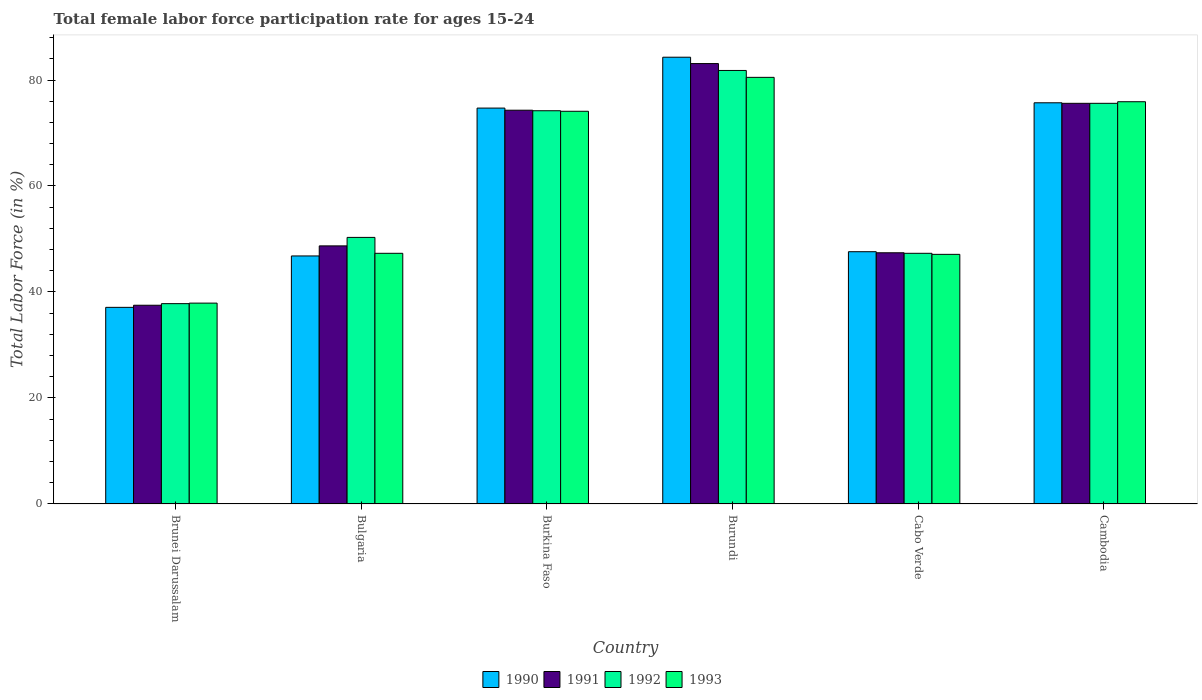How many bars are there on the 5th tick from the right?
Provide a succinct answer. 4. What is the female labor force participation rate in 1990 in Burundi?
Provide a succinct answer. 84.3. Across all countries, what is the maximum female labor force participation rate in 1993?
Make the answer very short. 80.5. Across all countries, what is the minimum female labor force participation rate in 1991?
Your answer should be compact. 37.5. In which country was the female labor force participation rate in 1992 maximum?
Make the answer very short. Burundi. In which country was the female labor force participation rate in 1992 minimum?
Keep it short and to the point. Brunei Darussalam. What is the total female labor force participation rate in 1991 in the graph?
Make the answer very short. 366.6. What is the difference between the female labor force participation rate in 1993 in Bulgaria and that in Burkina Faso?
Your response must be concise. -26.8. What is the difference between the female labor force participation rate in 1992 in Cabo Verde and the female labor force participation rate in 1991 in Burundi?
Make the answer very short. -35.8. What is the average female labor force participation rate in 1993 per country?
Your response must be concise. 60.47. What is the difference between the female labor force participation rate of/in 1990 and female labor force participation rate of/in 1992 in Brunei Darussalam?
Ensure brevity in your answer.  -0.7. What is the ratio of the female labor force participation rate in 1993 in Bulgaria to that in Cambodia?
Your answer should be compact. 0.62. What is the difference between the highest and the second highest female labor force participation rate in 1992?
Keep it short and to the point. 7.6. What is the difference between the highest and the lowest female labor force participation rate in 1993?
Give a very brief answer. 42.6. Is the sum of the female labor force participation rate in 1990 in Burundi and Cabo Verde greater than the maximum female labor force participation rate in 1991 across all countries?
Provide a short and direct response. Yes. Is it the case that in every country, the sum of the female labor force participation rate in 1990 and female labor force participation rate in 1993 is greater than the sum of female labor force participation rate in 1991 and female labor force participation rate in 1992?
Keep it short and to the point. No. What does the 4th bar from the left in Cambodia represents?
Provide a short and direct response. 1993. How many bars are there?
Offer a very short reply. 24. How many countries are there in the graph?
Make the answer very short. 6. What is the difference between two consecutive major ticks on the Y-axis?
Your response must be concise. 20. Are the values on the major ticks of Y-axis written in scientific E-notation?
Your response must be concise. No. Does the graph contain any zero values?
Ensure brevity in your answer.  No. Does the graph contain grids?
Provide a succinct answer. No. How are the legend labels stacked?
Offer a terse response. Horizontal. What is the title of the graph?
Keep it short and to the point. Total female labor force participation rate for ages 15-24. Does "2001" appear as one of the legend labels in the graph?
Your answer should be compact. No. What is the label or title of the X-axis?
Your answer should be very brief. Country. What is the label or title of the Y-axis?
Offer a terse response. Total Labor Force (in %). What is the Total Labor Force (in %) of 1990 in Brunei Darussalam?
Provide a succinct answer. 37.1. What is the Total Labor Force (in %) in 1991 in Brunei Darussalam?
Offer a very short reply. 37.5. What is the Total Labor Force (in %) of 1992 in Brunei Darussalam?
Provide a succinct answer. 37.8. What is the Total Labor Force (in %) of 1993 in Brunei Darussalam?
Keep it short and to the point. 37.9. What is the Total Labor Force (in %) of 1990 in Bulgaria?
Your answer should be compact. 46.8. What is the Total Labor Force (in %) in 1991 in Bulgaria?
Your answer should be very brief. 48.7. What is the Total Labor Force (in %) in 1992 in Bulgaria?
Offer a terse response. 50.3. What is the Total Labor Force (in %) of 1993 in Bulgaria?
Your answer should be very brief. 47.3. What is the Total Labor Force (in %) in 1990 in Burkina Faso?
Your response must be concise. 74.7. What is the Total Labor Force (in %) in 1991 in Burkina Faso?
Keep it short and to the point. 74.3. What is the Total Labor Force (in %) in 1992 in Burkina Faso?
Offer a terse response. 74.2. What is the Total Labor Force (in %) in 1993 in Burkina Faso?
Provide a succinct answer. 74.1. What is the Total Labor Force (in %) of 1990 in Burundi?
Give a very brief answer. 84.3. What is the Total Labor Force (in %) of 1991 in Burundi?
Your answer should be compact. 83.1. What is the Total Labor Force (in %) of 1992 in Burundi?
Your answer should be very brief. 81.8. What is the Total Labor Force (in %) of 1993 in Burundi?
Ensure brevity in your answer.  80.5. What is the Total Labor Force (in %) of 1990 in Cabo Verde?
Ensure brevity in your answer.  47.6. What is the Total Labor Force (in %) of 1991 in Cabo Verde?
Offer a very short reply. 47.4. What is the Total Labor Force (in %) in 1992 in Cabo Verde?
Ensure brevity in your answer.  47.3. What is the Total Labor Force (in %) in 1993 in Cabo Verde?
Your answer should be compact. 47.1. What is the Total Labor Force (in %) of 1990 in Cambodia?
Keep it short and to the point. 75.7. What is the Total Labor Force (in %) in 1991 in Cambodia?
Provide a short and direct response. 75.6. What is the Total Labor Force (in %) of 1992 in Cambodia?
Your response must be concise. 75.6. What is the Total Labor Force (in %) in 1993 in Cambodia?
Your answer should be very brief. 75.9. Across all countries, what is the maximum Total Labor Force (in %) of 1990?
Your answer should be compact. 84.3. Across all countries, what is the maximum Total Labor Force (in %) in 1991?
Your answer should be very brief. 83.1. Across all countries, what is the maximum Total Labor Force (in %) of 1992?
Offer a very short reply. 81.8. Across all countries, what is the maximum Total Labor Force (in %) in 1993?
Your answer should be compact. 80.5. Across all countries, what is the minimum Total Labor Force (in %) in 1990?
Keep it short and to the point. 37.1. Across all countries, what is the minimum Total Labor Force (in %) in 1991?
Ensure brevity in your answer.  37.5. Across all countries, what is the minimum Total Labor Force (in %) in 1992?
Your response must be concise. 37.8. Across all countries, what is the minimum Total Labor Force (in %) of 1993?
Offer a terse response. 37.9. What is the total Total Labor Force (in %) of 1990 in the graph?
Keep it short and to the point. 366.2. What is the total Total Labor Force (in %) in 1991 in the graph?
Provide a short and direct response. 366.6. What is the total Total Labor Force (in %) in 1992 in the graph?
Offer a terse response. 367. What is the total Total Labor Force (in %) of 1993 in the graph?
Your answer should be very brief. 362.8. What is the difference between the Total Labor Force (in %) of 1990 in Brunei Darussalam and that in Bulgaria?
Make the answer very short. -9.7. What is the difference between the Total Labor Force (in %) in 1991 in Brunei Darussalam and that in Bulgaria?
Offer a terse response. -11.2. What is the difference between the Total Labor Force (in %) of 1990 in Brunei Darussalam and that in Burkina Faso?
Offer a very short reply. -37.6. What is the difference between the Total Labor Force (in %) in 1991 in Brunei Darussalam and that in Burkina Faso?
Your answer should be compact. -36.8. What is the difference between the Total Labor Force (in %) in 1992 in Brunei Darussalam and that in Burkina Faso?
Your response must be concise. -36.4. What is the difference between the Total Labor Force (in %) of 1993 in Brunei Darussalam and that in Burkina Faso?
Offer a terse response. -36.2. What is the difference between the Total Labor Force (in %) of 1990 in Brunei Darussalam and that in Burundi?
Provide a short and direct response. -47.2. What is the difference between the Total Labor Force (in %) in 1991 in Brunei Darussalam and that in Burundi?
Ensure brevity in your answer.  -45.6. What is the difference between the Total Labor Force (in %) in 1992 in Brunei Darussalam and that in Burundi?
Offer a very short reply. -44. What is the difference between the Total Labor Force (in %) of 1993 in Brunei Darussalam and that in Burundi?
Keep it short and to the point. -42.6. What is the difference between the Total Labor Force (in %) in 1992 in Brunei Darussalam and that in Cabo Verde?
Keep it short and to the point. -9.5. What is the difference between the Total Labor Force (in %) in 1993 in Brunei Darussalam and that in Cabo Verde?
Make the answer very short. -9.2. What is the difference between the Total Labor Force (in %) in 1990 in Brunei Darussalam and that in Cambodia?
Your response must be concise. -38.6. What is the difference between the Total Labor Force (in %) in 1991 in Brunei Darussalam and that in Cambodia?
Provide a short and direct response. -38.1. What is the difference between the Total Labor Force (in %) in 1992 in Brunei Darussalam and that in Cambodia?
Ensure brevity in your answer.  -37.8. What is the difference between the Total Labor Force (in %) of 1993 in Brunei Darussalam and that in Cambodia?
Keep it short and to the point. -38. What is the difference between the Total Labor Force (in %) in 1990 in Bulgaria and that in Burkina Faso?
Provide a short and direct response. -27.9. What is the difference between the Total Labor Force (in %) of 1991 in Bulgaria and that in Burkina Faso?
Offer a terse response. -25.6. What is the difference between the Total Labor Force (in %) of 1992 in Bulgaria and that in Burkina Faso?
Your response must be concise. -23.9. What is the difference between the Total Labor Force (in %) of 1993 in Bulgaria and that in Burkina Faso?
Keep it short and to the point. -26.8. What is the difference between the Total Labor Force (in %) in 1990 in Bulgaria and that in Burundi?
Keep it short and to the point. -37.5. What is the difference between the Total Labor Force (in %) in 1991 in Bulgaria and that in Burundi?
Offer a terse response. -34.4. What is the difference between the Total Labor Force (in %) in 1992 in Bulgaria and that in Burundi?
Provide a succinct answer. -31.5. What is the difference between the Total Labor Force (in %) of 1993 in Bulgaria and that in Burundi?
Your response must be concise. -33.2. What is the difference between the Total Labor Force (in %) in 1990 in Bulgaria and that in Cabo Verde?
Offer a very short reply. -0.8. What is the difference between the Total Labor Force (in %) in 1990 in Bulgaria and that in Cambodia?
Offer a very short reply. -28.9. What is the difference between the Total Labor Force (in %) of 1991 in Bulgaria and that in Cambodia?
Ensure brevity in your answer.  -26.9. What is the difference between the Total Labor Force (in %) of 1992 in Bulgaria and that in Cambodia?
Provide a short and direct response. -25.3. What is the difference between the Total Labor Force (in %) in 1993 in Bulgaria and that in Cambodia?
Your answer should be compact. -28.6. What is the difference between the Total Labor Force (in %) of 1992 in Burkina Faso and that in Burundi?
Give a very brief answer. -7.6. What is the difference between the Total Labor Force (in %) in 1993 in Burkina Faso and that in Burundi?
Provide a short and direct response. -6.4. What is the difference between the Total Labor Force (in %) in 1990 in Burkina Faso and that in Cabo Verde?
Offer a terse response. 27.1. What is the difference between the Total Labor Force (in %) of 1991 in Burkina Faso and that in Cabo Verde?
Provide a succinct answer. 26.9. What is the difference between the Total Labor Force (in %) of 1992 in Burkina Faso and that in Cabo Verde?
Offer a very short reply. 26.9. What is the difference between the Total Labor Force (in %) in 1993 in Burkina Faso and that in Cambodia?
Make the answer very short. -1.8. What is the difference between the Total Labor Force (in %) of 1990 in Burundi and that in Cabo Verde?
Provide a short and direct response. 36.7. What is the difference between the Total Labor Force (in %) in 1991 in Burundi and that in Cabo Verde?
Keep it short and to the point. 35.7. What is the difference between the Total Labor Force (in %) of 1992 in Burundi and that in Cabo Verde?
Keep it short and to the point. 34.5. What is the difference between the Total Labor Force (in %) in 1993 in Burundi and that in Cabo Verde?
Your answer should be compact. 33.4. What is the difference between the Total Labor Force (in %) in 1991 in Burundi and that in Cambodia?
Make the answer very short. 7.5. What is the difference between the Total Labor Force (in %) of 1993 in Burundi and that in Cambodia?
Ensure brevity in your answer.  4.6. What is the difference between the Total Labor Force (in %) in 1990 in Cabo Verde and that in Cambodia?
Keep it short and to the point. -28.1. What is the difference between the Total Labor Force (in %) of 1991 in Cabo Verde and that in Cambodia?
Your response must be concise. -28.2. What is the difference between the Total Labor Force (in %) in 1992 in Cabo Verde and that in Cambodia?
Keep it short and to the point. -28.3. What is the difference between the Total Labor Force (in %) of 1993 in Cabo Verde and that in Cambodia?
Your response must be concise. -28.8. What is the difference between the Total Labor Force (in %) in 1990 in Brunei Darussalam and the Total Labor Force (in %) in 1992 in Bulgaria?
Make the answer very short. -13.2. What is the difference between the Total Labor Force (in %) in 1990 in Brunei Darussalam and the Total Labor Force (in %) in 1991 in Burkina Faso?
Keep it short and to the point. -37.2. What is the difference between the Total Labor Force (in %) in 1990 in Brunei Darussalam and the Total Labor Force (in %) in 1992 in Burkina Faso?
Make the answer very short. -37.1. What is the difference between the Total Labor Force (in %) of 1990 in Brunei Darussalam and the Total Labor Force (in %) of 1993 in Burkina Faso?
Your response must be concise. -37. What is the difference between the Total Labor Force (in %) of 1991 in Brunei Darussalam and the Total Labor Force (in %) of 1992 in Burkina Faso?
Provide a succinct answer. -36.7. What is the difference between the Total Labor Force (in %) of 1991 in Brunei Darussalam and the Total Labor Force (in %) of 1993 in Burkina Faso?
Your response must be concise. -36.6. What is the difference between the Total Labor Force (in %) in 1992 in Brunei Darussalam and the Total Labor Force (in %) in 1993 in Burkina Faso?
Offer a terse response. -36.3. What is the difference between the Total Labor Force (in %) of 1990 in Brunei Darussalam and the Total Labor Force (in %) of 1991 in Burundi?
Your answer should be compact. -46. What is the difference between the Total Labor Force (in %) in 1990 in Brunei Darussalam and the Total Labor Force (in %) in 1992 in Burundi?
Offer a very short reply. -44.7. What is the difference between the Total Labor Force (in %) of 1990 in Brunei Darussalam and the Total Labor Force (in %) of 1993 in Burundi?
Your answer should be very brief. -43.4. What is the difference between the Total Labor Force (in %) of 1991 in Brunei Darussalam and the Total Labor Force (in %) of 1992 in Burundi?
Make the answer very short. -44.3. What is the difference between the Total Labor Force (in %) in 1991 in Brunei Darussalam and the Total Labor Force (in %) in 1993 in Burundi?
Your answer should be very brief. -43. What is the difference between the Total Labor Force (in %) of 1992 in Brunei Darussalam and the Total Labor Force (in %) of 1993 in Burundi?
Keep it short and to the point. -42.7. What is the difference between the Total Labor Force (in %) of 1990 in Brunei Darussalam and the Total Labor Force (in %) of 1991 in Cabo Verde?
Ensure brevity in your answer.  -10.3. What is the difference between the Total Labor Force (in %) in 1990 in Brunei Darussalam and the Total Labor Force (in %) in 1992 in Cabo Verde?
Provide a succinct answer. -10.2. What is the difference between the Total Labor Force (in %) in 1990 in Brunei Darussalam and the Total Labor Force (in %) in 1993 in Cabo Verde?
Your response must be concise. -10. What is the difference between the Total Labor Force (in %) in 1991 in Brunei Darussalam and the Total Labor Force (in %) in 1993 in Cabo Verde?
Your answer should be very brief. -9.6. What is the difference between the Total Labor Force (in %) of 1990 in Brunei Darussalam and the Total Labor Force (in %) of 1991 in Cambodia?
Provide a succinct answer. -38.5. What is the difference between the Total Labor Force (in %) of 1990 in Brunei Darussalam and the Total Labor Force (in %) of 1992 in Cambodia?
Give a very brief answer. -38.5. What is the difference between the Total Labor Force (in %) in 1990 in Brunei Darussalam and the Total Labor Force (in %) in 1993 in Cambodia?
Your answer should be very brief. -38.8. What is the difference between the Total Labor Force (in %) in 1991 in Brunei Darussalam and the Total Labor Force (in %) in 1992 in Cambodia?
Your response must be concise. -38.1. What is the difference between the Total Labor Force (in %) in 1991 in Brunei Darussalam and the Total Labor Force (in %) in 1993 in Cambodia?
Your answer should be very brief. -38.4. What is the difference between the Total Labor Force (in %) in 1992 in Brunei Darussalam and the Total Labor Force (in %) in 1993 in Cambodia?
Keep it short and to the point. -38.1. What is the difference between the Total Labor Force (in %) in 1990 in Bulgaria and the Total Labor Force (in %) in 1991 in Burkina Faso?
Provide a succinct answer. -27.5. What is the difference between the Total Labor Force (in %) in 1990 in Bulgaria and the Total Labor Force (in %) in 1992 in Burkina Faso?
Offer a very short reply. -27.4. What is the difference between the Total Labor Force (in %) of 1990 in Bulgaria and the Total Labor Force (in %) of 1993 in Burkina Faso?
Offer a very short reply. -27.3. What is the difference between the Total Labor Force (in %) of 1991 in Bulgaria and the Total Labor Force (in %) of 1992 in Burkina Faso?
Provide a succinct answer. -25.5. What is the difference between the Total Labor Force (in %) of 1991 in Bulgaria and the Total Labor Force (in %) of 1993 in Burkina Faso?
Your answer should be compact. -25.4. What is the difference between the Total Labor Force (in %) in 1992 in Bulgaria and the Total Labor Force (in %) in 1993 in Burkina Faso?
Keep it short and to the point. -23.8. What is the difference between the Total Labor Force (in %) in 1990 in Bulgaria and the Total Labor Force (in %) in 1991 in Burundi?
Your answer should be compact. -36.3. What is the difference between the Total Labor Force (in %) of 1990 in Bulgaria and the Total Labor Force (in %) of 1992 in Burundi?
Your response must be concise. -35. What is the difference between the Total Labor Force (in %) of 1990 in Bulgaria and the Total Labor Force (in %) of 1993 in Burundi?
Ensure brevity in your answer.  -33.7. What is the difference between the Total Labor Force (in %) in 1991 in Bulgaria and the Total Labor Force (in %) in 1992 in Burundi?
Keep it short and to the point. -33.1. What is the difference between the Total Labor Force (in %) in 1991 in Bulgaria and the Total Labor Force (in %) in 1993 in Burundi?
Offer a terse response. -31.8. What is the difference between the Total Labor Force (in %) in 1992 in Bulgaria and the Total Labor Force (in %) in 1993 in Burundi?
Your answer should be very brief. -30.2. What is the difference between the Total Labor Force (in %) of 1990 in Bulgaria and the Total Labor Force (in %) of 1992 in Cabo Verde?
Keep it short and to the point. -0.5. What is the difference between the Total Labor Force (in %) of 1991 in Bulgaria and the Total Labor Force (in %) of 1992 in Cabo Verde?
Provide a short and direct response. 1.4. What is the difference between the Total Labor Force (in %) of 1990 in Bulgaria and the Total Labor Force (in %) of 1991 in Cambodia?
Your answer should be very brief. -28.8. What is the difference between the Total Labor Force (in %) of 1990 in Bulgaria and the Total Labor Force (in %) of 1992 in Cambodia?
Provide a short and direct response. -28.8. What is the difference between the Total Labor Force (in %) in 1990 in Bulgaria and the Total Labor Force (in %) in 1993 in Cambodia?
Make the answer very short. -29.1. What is the difference between the Total Labor Force (in %) of 1991 in Bulgaria and the Total Labor Force (in %) of 1992 in Cambodia?
Give a very brief answer. -26.9. What is the difference between the Total Labor Force (in %) of 1991 in Bulgaria and the Total Labor Force (in %) of 1993 in Cambodia?
Keep it short and to the point. -27.2. What is the difference between the Total Labor Force (in %) in 1992 in Bulgaria and the Total Labor Force (in %) in 1993 in Cambodia?
Your answer should be compact. -25.6. What is the difference between the Total Labor Force (in %) of 1990 in Burkina Faso and the Total Labor Force (in %) of 1991 in Burundi?
Offer a very short reply. -8.4. What is the difference between the Total Labor Force (in %) in 1990 in Burkina Faso and the Total Labor Force (in %) in 1992 in Burundi?
Your answer should be compact. -7.1. What is the difference between the Total Labor Force (in %) in 1990 in Burkina Faso and the Total Labor Force (in %) in 1993 in Burundi?
Keep it short and to the point. -5.8. What is the difference between the Total Labor Force (in %) of 1991 in Burkina Faso and the Total Labor Force (in %) of 1992 in Burundi?
Your answer should be very brief. -7.5. What is the difference between the Total Labor Force (in %) in 1990 in Burkina Faso and the Total Labor Force (in %) in 1991 in Cabo Verde?
Your response must be concise. 27.3. What is the difference between the Total Labor Force (in %) in 1990 in Burkina Faso and the Total Labor Force (in %) in 1992 in Cabo Verde?
Your answer should be very brief. 27.4. What is the difference between the Total Labor Force (in %) in 1990 in Burkina Faso and the Total Labor Force (in %) in 1993 in Cabo Verde?
Provide a short and direct response. 27.6. What is the difference between the Total Labor Force (in %) of 1991 in Burkina Faso and the Total Labor Force (in %) of 1992 in Cabo Verde?
Ensure brevity in your answer.  27. What is the difference between the Total Labor Force (in %) in 1991 in Burkina Faso and the Total Labor Force (in %) in 1993 in Cabo Verde?
Give a very brief answer. 27.2. What is the difference between the Total Labor Force (in %) of 1992 in Burkina Faso and the Total Labor Force (in %) of 1993 in Cabo Verde?
Your answer should be compact. 27.1. What is the difference between the Total Labor Force (in %) in 1990 in Burkina Faso and the Total Labor Force (in %) in 1992 in Cambodia?
Make the answer very short. -0.9. What is the difference between the Total Labor Force (in %) in 1991 in Burkina Faso and the Total Labor Force (in %) in 1993 in Cambodia?
Your answer should be compact. -1.6. What is the difference between the Total Labor Force (in %) of 1992 in Burkina Faso and the Total Labor Force (in %) of 1993 in Cambodia?
Make the answer very short. -1.7. What is the difference between the Total Labor Force (in %) of 1990 in Burundi and the Total Labor Force (in %) of 1991 in Cabo Verde?
Offer a very short reply. 36.9. What is the difference between the Total Labor Force (in %) of 1990 in Burundi and the Total Labor Force (in %) of 1992 in Cabo Verde?
Offer a terse response. 37. What is the difference between the Total Labor Force (in %) in 1990 in Burundi and the Total Labor Force (in %) in 1993 in Cabo Verde?
Your answer should be compact. 37.2. What is the difference between the Total Labor Force (in %) of 1991 in Burundi and the Total Labor Force (in %) of 1992 in Cabo Verde?
Your answer should be very brief. 35.8. What is the difference between the Total Labor Force (in %) of 1992 in Burundi and the Total Labor Force (in %) of 1993 in Cabo Verde?
Offer a very short reply. 34.7. What is the difference between the Total Labor Force (in %) in 1990 in Burundi and the Total Labor Force (in %) in 1992 in Cambodia?
Give a very brief answer. 8.7. What is the difference between the Total Labor Force (in %) in 1991 in Burundi and the Total Labor Force (in %) in 1992 in Cambodia?
Provide a short and direct response. 7.5. What is the difference between the Total Labor Force (in %) of 1991 in Burundi and the Total Labor Force (in %) of 1993 in Cambodia?
Make the answer very short. 7.2. What is the difference between the Total Labor Force (in %) of 1992 in Burundi and the Total Labor Force (in %) of 1993 in Cambodia?
Make the answer very short. 5.9. What is the difference between the Total Labor Force (in %) of 1990 in Cabo Verde and the Total Labor Force (in %) of 1991 in Cambodia?
Keep it short and to the point. -28. What is the difference between the Total Labor Force (in %) of 1990 in Cabo Verde and the Total Labor Force (in %) of 1993 in Cambodia?
Give a very brief answer. -28.3. What is the difference between the Total Labor Force (in %) in 1991 in Cabo Verde and the Total Labor Force (in %) in 1992 in Cambodia?
Your answer should be compact. -28.2. What is the difference between the Total Labor Force (in %) of 1991 in Cabo Verde and the Total Labor Force (in %) of 1993 in Cambodia?
Keep it short and to the point. -28.5. What is the difference between the Total Labor Force (in %) of 1992 in Cabo Verde and the Total Labor Force (in %) of 1993 in Cambodia?
Your response must be concise. -28.6. What is the average Total Labor Force (in %) in 1990 per country?
Keep it short and to the point. 61.03. What is the average Total Labor Force (in %) in 1991 per country?
Ensure brevity in your answer.  61.1. What is the average Total Labor Force (in %) of 1992 per country?
Provide a short and direct response. 61.17. What is the average Total Labor Force (in %) in 1993 per country?
Provide a succinct answer. 60.47. What is the difference between the Total Labor Force (in %) of 1990 and Total Labor Force (in %) of 1992 in Brunei Darussalam?
Offer a very short reply. -0.7. What is the difference between the Total Labor Force (in %) of 1990 and Total Labor Force (in %) of 1993 in Brunei Darussalam?
Provide a succinct answer. -0.8. What is the difference between the Total Labor Force (in %) of 1991 and Total Labor Force (in %) of 1993 in Brunei Darussalam?
Provide a succinct answer. -0.4. What is the difference between the Total Labor Force (in %) in 1992 and Total Labor Force (in %) in 1993 in Brunei Darussalam?
Make the answer very short. -0.1. What is the difference between the Total Labor Force (in %) in 1990 and Total Labor Force (in %) in 1991 in Bulgaria?
Ensure brevity in your answer.  -1.9. What is the difference between the Total Labor Force (in %) in 1991 and Total Labor Force (in %) in 1992 in Bulgaria?
Make the answer very short. -1.6. What is the difference between the Total Labor Force (in %) in 1990 and Total Labor Force (in %) in 1991 in Burkina Faso?
Make the answer very short. 0.4. What is the difference between the Total Labor Force (in %) in 1990 and Total Labor Force (in %) in 1993 in Burkina Faso?
Provide a short and direct response. 0.6. What is the difference between the Total Labor Force (in %) of 1991 and Total Labor Force (in %) of 1992 in Burkina Faso?
Ensure brevity in your answer.  0.1. What is the difference between the Total Labor Force (in %) of 1991 and Total Labor Force (in %) of 1993 in Burkina Faso?
Your response must be concise. 0.2. What is the difference between the Total Labor Force (in %) of 1992 and Total Labor Force (in %) of 1993 in Burkina Faso?
Make the answer very short. 0.1. What is the difference between the Total Labor Force (in %) in 1990 and Total Labor Force (in %) in 1991 in Burundi?
Ensure brevity in your answer.  1.2. What is the difference between the Total Labor Force (in %) in 1990 and Total Labor Force (in %) in 1992 in Burundi?
Your response must be concise. 2.5. What is the difference between the Total Labor Force (in %) of 1990 and Total Labor Force (in %) of 1993 in Burundi?
Your answer should be compact. 3.8. What is the difference between the Total Labor Force (in %) in 1991 and Total Labor Force (in %) in 1993 in Burundi?
Keep it short and to the point. 2.6. What is the difference between the Total Labor Force (in %) in 1990 and Total Labor Force (in %) in 1991 in Cabo Verde?
Your answer should be very brief. 0.2. What is the difference between the Total Labor Force (in %) of 1991 and Total Labor Force (in %) of 1992 in Cabo Verde?
Your answer should be compact. 0.1. What is the difference between the Total Labor Force (in %) in 1990 and Total Labor Force (in %) in 1991 in Cambodia?
Your answer should be compact. 0.1. What is the difference between the Total Labor Force (in %) of 1990 and Total Labor Force (in %) of 1992 in Cambodia?
Make the answer very short. 0.1. What is the difference between the Total Labor Force (in %) of 1990 and Total Labor Force (in %) of 1993 in Cambodia?
Provide a succinct answer. -0.2. What is the difference between the Total Labor Force (in %) of 1991 and Total Labor Force (in %) of 1992 in Cambodia?
Keep it short and to the point. 0. What is the difference between the Total Labor Force (in %) of 1991 and Total Labor Force (in %) of 1993 in Cambodia?
Provide a short and direct response. -0.3. What is the difference between the Total Labor Force (in %) of 1992 and Total Labor Force (in %) of 1993 in Cambodia?
Keep it short and to the point. -0.3. What is the ratio of the Total Labor Force (in %) in 1990 in Brunei Darussalam to that in Bulgaria?
Provide a succinct answer. 0.79. What is the ratio of the Total Labor Force (in %) of 1991 in Brunei Darussalam to that in Bulgaria?
Ensure brevity in your answer.  0.77. What is the ratio of the Total Labor Force (in %) of 1992 in Brunei Darussalam to that in Bulgaria?
Your response must be concise. 0.75. What is the ratio of the Total Labor Force (in %) of 1993 in Brunei Darussalam to that in Bulgaria?
Provide a succinct answer. 0.8. What is the ratio of the Total Labor Force (in %) of 1990 in Brunei Darussalam to that in Burkina Faso?
Keep it short and to the point. 0.5. What is the ratio of the Total Labor Force (in %) of 1991 in Brunei Darussalam to that in Burkina Faso?
Your response must be concise. 0.5. What is the ratio of the Total Labor Force (in %) of 1992 in Brunei Darussalam to that in Burkina Faso?
Provide a short and direct response. 0.51. What is the ratio of the Total Labor Force (in %) in 1993 in Brunei Darussalam to that in Burkina Faso?
Give a very brief answer. 0.51. What is the ratio of the Total Labor Force (in %) in 1990 in Brunei Darussalam to that in Burundi?
Provide a short and direct response. 0.44. What is the ratio of the Total Labor Force (in %) of 1991 in Brunei Darussalam to that in Burundi?
Provide a succinct answer. 0.45. What is the ratio of the Total Labor Force (in %) in 1992 in Brunei Darussalam to that in Burundi?
Give a very brief answer. 0.46. What is the ratio of the Total Labor Force (in %) in 1993 in Brunei Darussalam to that in Burundi?
Give a very brief answer. 0.47. What is the ratio of the Total Labor Force (in %) of 1990 in Brunei Darussalam to that in Cabo Verde?
Give a very brief answer. 0.78. What is the ratio of the Total Labor Force (in %) in 1991 in Brunei Darussalam to that in Cabo Verde?
Ensure brevity in your answer.  0.79. What is the ratio of the Total Labor Force (in %) in 1992 in Brunei Darussalam to that in Cabo Verde?
Offer a very short reply. 0.8. What is the ratio of the Total Labor Force (in %) of 1993 in Brunei Darussalam to that in Cabo Verde?
Offer a terse response. 0.8. What is the ratio of the Total Labor Force (in %) in 1990 in Brunei Darussalam to that in Cambodia?
Your response must be concise. 0.49. What is the ratio of the Total Labor Force (in %) in 1991 in Brunei Darussalam to that in Cambodia?
Your answer should be very brief. 0.5. What is the ratio of the Total Labor Force (in %) in 1993 in Brunei Darussalam to that in Cambodia?
Give a very brief answer. 0.5. What is the ratio of the Total Labor Force (in %) in 1990 in Bulgaria to that in Burkina Faso?
Your response must be concise. 0.63. What is the ratio of the Total Labor Force (in %) in 1991 in Bulgaria to that in Burkina Faso?
Your response must be concise. 0.66. What is the ratio of the Total Labor Force (in %) in 1992 in Bulgaria to that in Burkina Faso?
Your answer should be compact. 0.68. What is the ratio of the Total Labor Force (in %) of 1993 in Bulgaria to that in Burkina Faso?
Give a very brief answer. 0.64. What is the ratio of the Total Labor Force (in %) of 1990 in Bulgaria to that in Burundi?
Your answer should be compact. 0.56. What is the ratio of the Total Labor Force (in %) in 1991 in Bulgaria to that in Burundi?
Keep it short and to the point. 0.59. What is the ratio of the Total Labor Force (in %) of 1992 in Bulgaria to that in Burundi?
Offer a very short reply. 0.61. What is the ratio of the Total Labor Force (in %) of 1993 in Bulgaria to that in Burundi?
Ensure brevity in your answer.  0.59. What is the ratio of the Total Labor Force (in %) in 1990 in Bulgaria to that in Cabo Verde?
Provide a succinct answer. 0.98. What is the ratio of the Total Labor Force (in %) in 1991 in Bulgaria to that in Cabo Verde?
Your response must be concise. 1.03. What is the ratio of the Total Labor Force (in %) in 1992 in Bulgaria to that in Cabo Verde?
Give a very brief answer. 1.06. What is the ratio of the Total Labor Force (in %) in 1990 in Bulgaria to that in Cambodia?
Keep it short and to the point. 0.62. What is the ratio of the Total Labor Force (in %) of 1991 in Bulgaria to that in Cambodia?
Give a very brief answer. 0.64. What is the ratio of the Total Labor Force (in %) in 1992 in Bulgaria to that in Cambodia?
Your answer should be compact. 0.67. What is the ratio of the Total Labor Force (in %) in 1993 in Bulgaria to that in Cambodia?
Your answer should be compact. 0.62. What is the ratio of the Total Labor Force (in %) in 1990 in Burkina Faso to that in Burundi?
Ensure brevity in your answer.  0.89. What is the ratio of the Total Labor Force (in %) in 1991 in Burkina Faso to that in Burundi?
Your response must be concise. 0.89. What is the ratio of the Total Labor Force (in %) in 1992 in Burkina Faso to that in Burundi?
Provide a short and direct response. 0.91. What is the ratio of the Total Labor Force (in %) in 1993 in Burkina Faso to that in Burundi?
Give a very brief answer. 0.92. What is the ratio of the Total Labor Force (in %) of 1990 in Burkina Faso to that in Cabo Verde?
Keep it short and to the point. 1.57. What is the ratio of the Total Labor Force (in %) of 1991 in Burkina Faso to that in Cabo Verde?
Your answer should be very brief. 1.57. What is the ratio of the Total Labor Force (in %) in 1992 in Burkina Faso to that in Cabo Verde?
Offer a terse response. 1.57. What is the ratio of the Total Labor Force (in %) in 1993 in Burkina Faso to that in Cabo Verde?
Your answer should be very brief. 1.57. What is the ratio of the Total Labor Force (in %) of 1990 in Burkina Faso to that in Cambodia?
Give a very brief answer. 0.99. What is the ratio of the Total Labor Force (in %) in 1991 in Burkina Faso to that in Cambodia?
Your answer should be very brief. 0.98. What is the ratio of the Total Labor Force (in %) in 1992 in Burkina Faso to that in Cambodia?
Your answer should be compact. 0.98. What is the ratio of the Total Labor Force (in %) in 1993 in Burkina Faso to that in Cambodia?
Your answer should be very brief. 0.98. What is the ratio of the Total Labor Force (in %) in 1990 in Burundi to that in Cabo Verde?
Offer a very short reply. 1.77. What is the ratio of the Total Labor Force (in %) in 1991 in Burundi to that in Cabo Verde?
Ensure brevity in your answer.  1.75. What is the ratio of the Total Labor Force (in %) in 1992 in Burundi to that in Cabo Verde?
Your answer should be very brief. 1.73. What is the ratio of the Total Labor Force (in %) of 1993 in Burundi to that in Cabo Verde?
Provide a succinct answer. 1.71. What is the ratio of the Total Labor Force (in %) of 1990 in Burundi to that in Cambodia?
Offer a very short reply. 1.11. What is the ratio of the Total Labor Force (in %) in 1991 in Burundi to that in Cambodia?
Your response must be concise. 1.1. What is the ratio of the Total Labor Force (in %) of 1992 in Burundi to that in Cambodia?
Offer a terse response. 1.08. What is the ratio of the Total Labor Force (in %) of 1993 in Burundi to that in Cambodia?
Keep it short and to the point. 1.06. What is the ratio of the Total Labor Force (in %) in 1990 in Cabo Verde to that in Cambodia?
Your response must be concise. 0.63. What is the ratio of the Total Labor Force (in %) of 1991 in Cabo Verde to that in Cambodia?
Offer a very short reply. 0.63. What is the ratio of the Total Labor Force (in %) in 1992 in Cabo Verde to that in Cambodia?
Give a very brief answer. 0.63. What is the ratio of the Total Labor Force (in %) in 1993 in Cabo Verde to that in Cambodia?
Provide a short and direct response. 0.62. What is the difference between the highest and the second highest Total Labor Force (in %) in 1991?
Your answer should be compact. 7.5. What is the difference between the highest and the second highest Total Labor Force (in %) of 1992?
Offer a very short reply. 6.2. What is the difference between the highest and the second highest Total Labor Force (in %) of 1993?
Ensure brevity in your answer.  4.6. What is the difference between the highest and the lowest Total Labor Force (in %) in 1990?
Provide a short and direct response. 47.2. What is the difference between the highest and the lowest Total Labor Force (in %) of 1991?
Make the answer very short. 45.6. What is the difference between the highest and the lowest Total Labor Force (in %) of 1993?
Make the answer very short. 42.6. 